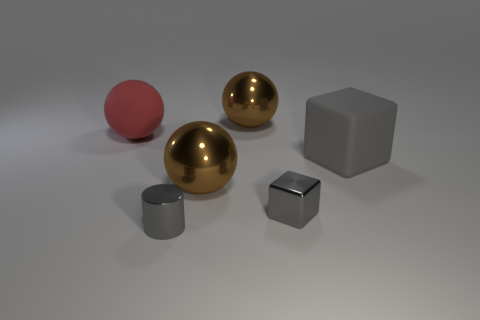Add 3 large spheres. How many objects exist? 9 Subtract all cylinders. How many objects are left? 5 Add 1 gray matte objects. How many gray matte objects are left? 2 Add 2 yellow matte cylinders. How many yellow matte cylinders exist? 2 Subtract 2 gray blocks. How many objects are left? 4 Subtract all rubber spheres. Subtract all rubber objects. How many objects are left? 3 